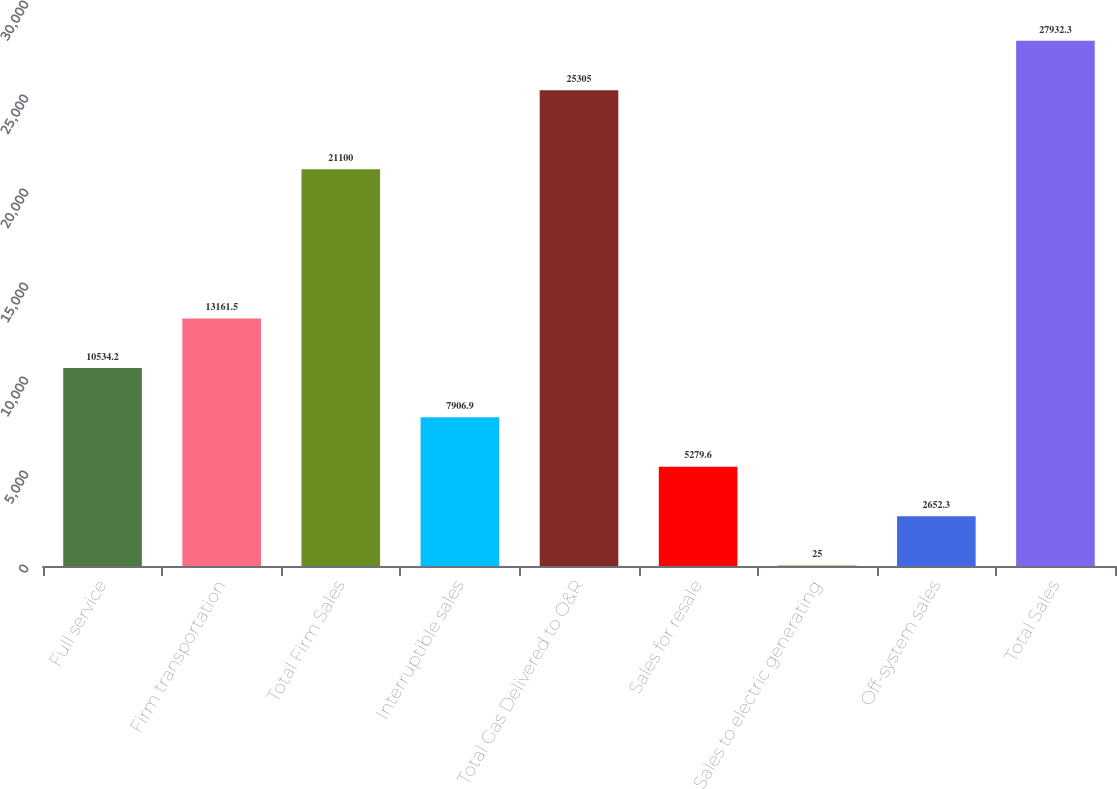Convert chart to OTSL. <chart><loc_0><loc_0><loc_500><loc_500><bar_chart><fcel>Full service<fcel>Firm transportation<fcel>Total Firm Sales<fcel>Interruptible sales<fcel>Total Gas Delivered to O&R<fcel>Sales for resale<fcel>Sales to electric generating<fcel>Off-system sales<fcel>Total Sales<nl><fcel>10534.2<fcel>13161.5<fcel>21100<fcel>7906.9<fcel>25305<fcel>5279.6<fcel>25<fcel>2652.3<fcel>27932.3<nl></chart> 